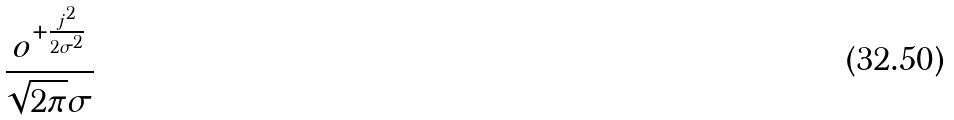<formula> <loc_0><loc_0><loc_500><loc_500>\frac { o ^ { + \frac { j ^ { 2 } } { 2 \sigma ^ { 2 } } } } { \sqrt { 2 \pi } \sigma }</formula> 